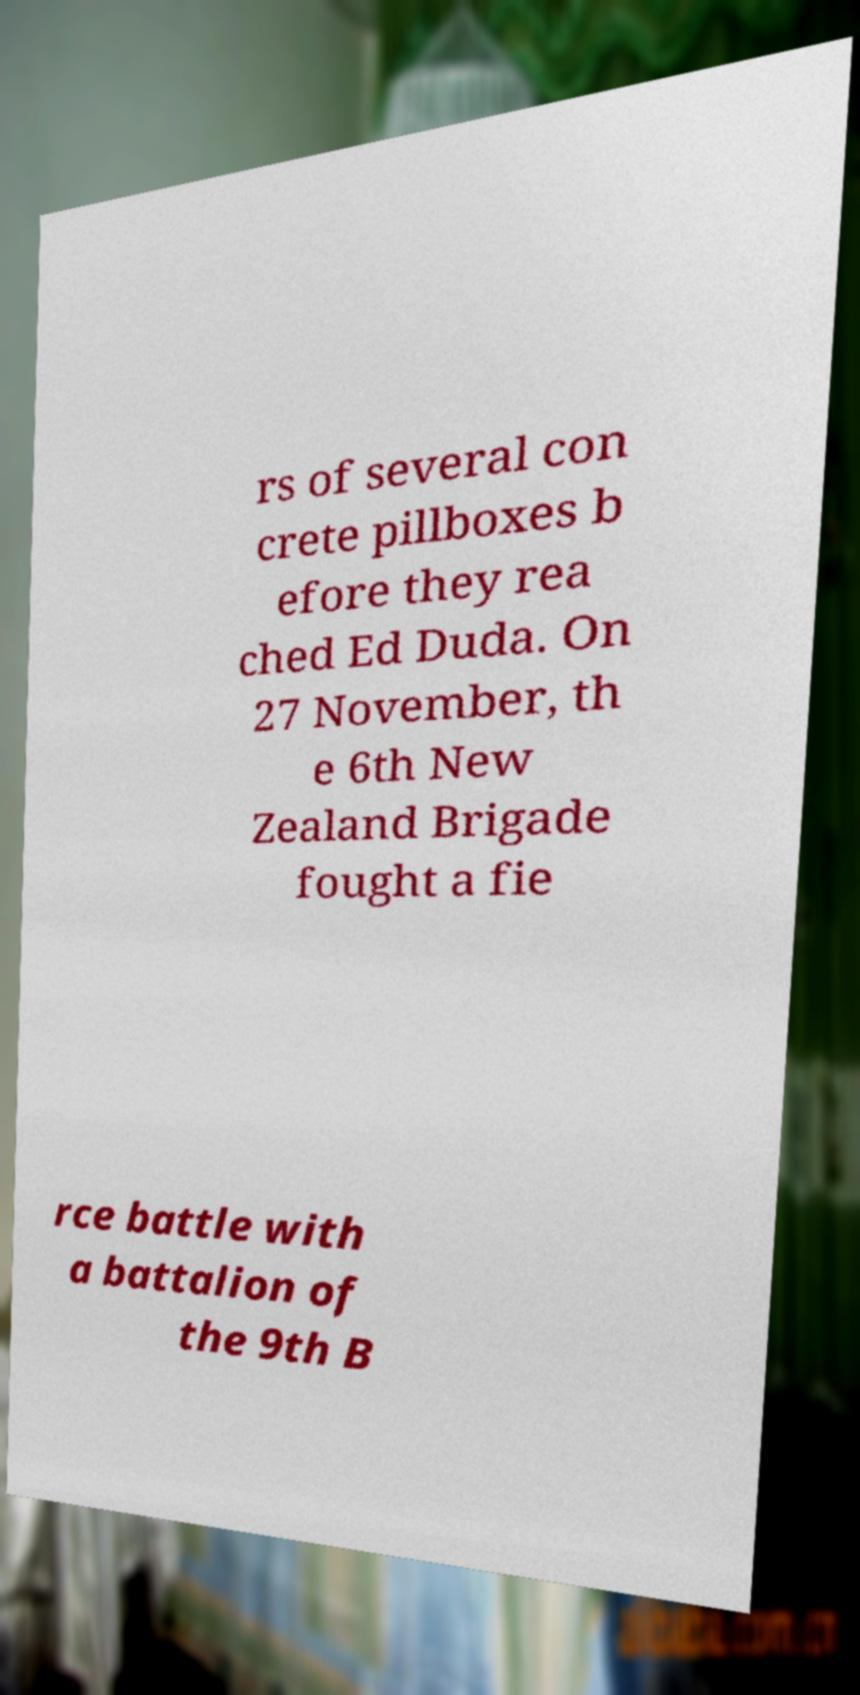For documentation purposes, I need the text within this image transcribed. Could you provide that? rs of several con crete pillboxes b efore they rea ched Ed Duda. On 27 November, th e 6th New Zealand Brigade fought a fie rce battle with a battalion of the 9th B 